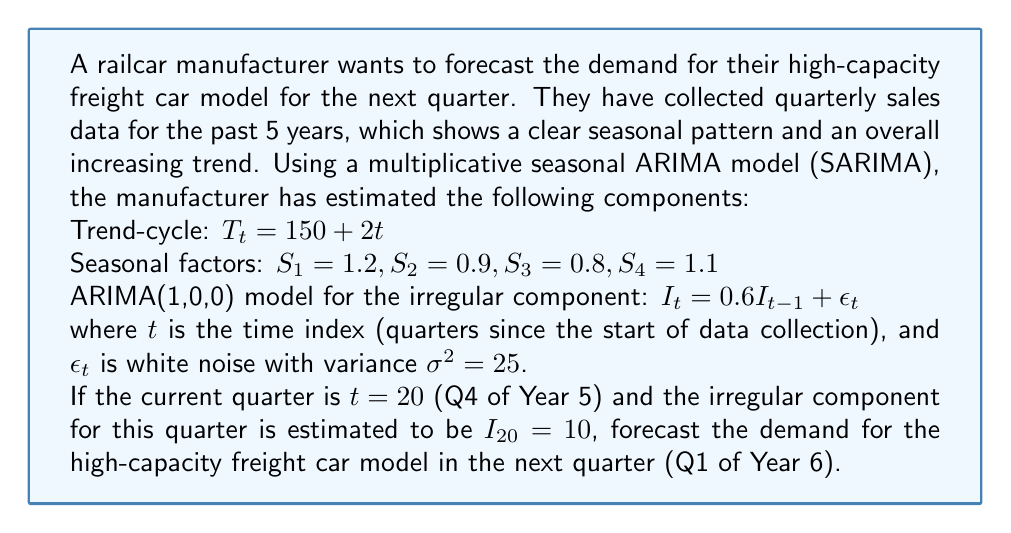Can you solve this math problem? To forecast the demand for the next quarter, we need to combine the trend-cycle, seasonal, and irregular components using the multiplicative SARIMA model. Let's break this down step-by-step:

1. Identify the components for the next quarter (t = 21):

   Trend-cycle: $T_{21} = 150 + 2(21) = 192$
   Seasonal factor: $S_1 = 1.2$ (as Q1 is the first quarter of the year)
   
2. Forecast the irregular component:
   
   Using the ARIMA(1,0,0) model: $I_{21} = 0.6I_{20} + \epsilon_{21}$
   
   We know $I_{20} = 10$, but we don't know $\epsilon_{21}$. For forecasting, we use its expected value, which is 0.
   
   So, $E[I_{21}] = 0.6(10) + 0 = 6$

3. Combine the components using the multiplicative model:

   $Y_{21} = T_{21} \times S_1 \times E[I_{21}]$
   
   $Y_{21} = 192 \times 1.2 \times 6$

4. Calculate the final forecast:

   $Y_{21} = 192 \times 1.2 \times 6 = 1,382.4$

Therefore, the forecast demand for the high-capacity freight car model in Q1 of Year 6 is approximately 1,382 units.

Note: The actual realization may differ due to the random component $\epsilon_{21}$. We can calculate prediction intervals to account for this uncertainty, but that's beyond the scope of this question.
Answer: 1,382 units (rounded to the nearest whole number) 